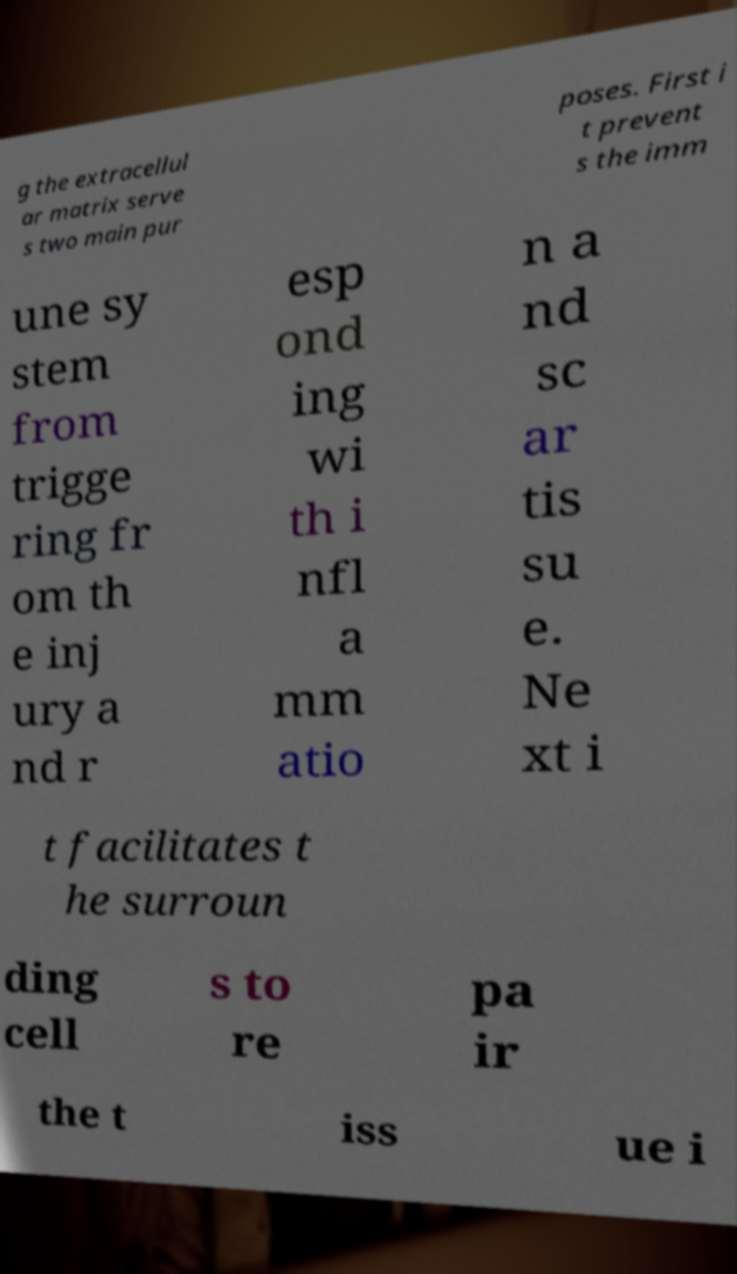What messages or text are displayed in this image? I need them in a readable, typed format. g the extracellul ar matrix serve s two main pur poses. First i t prevent s the imm une sy stem from trigge ring fr om th e inj ury a nd r esp ond ing wi th i nfl a mm atio n a nd sc ar tis su e. Ne xt i t facilitates t he surroun ding cell s to re pa ir the t iss ue i 